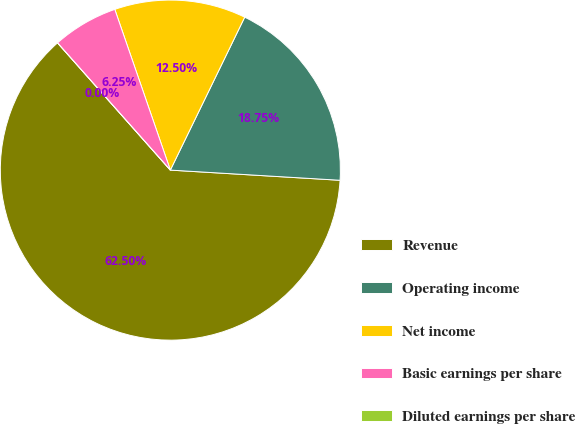Convert chart. <chart><loc_0><loc_0><loc_500><loc_500><pie_chart><fcel>Revenue<fcel>Operating income<fcel>Net income<fcel>Basic earnings per share<fcel>Diluted earnings per share<nl><fcel>62.5%<fcel>18.75%<fcel>12.5%<fcel>6.25%<fcel>0.0%<nl></chart> 